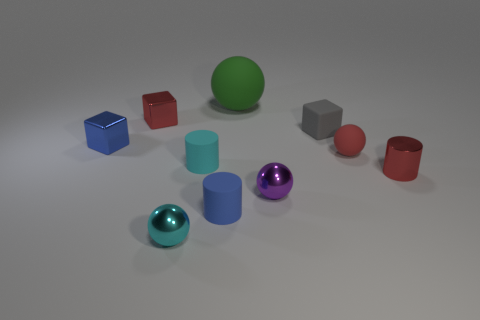Are there any other things that are the same size as the green object?
Keep it short and to the point. No. Is the material of the cyan cylinder the same as the gray thing?
Offer a very short reply. Yes. What number of objects are either tiny red cylinders or big yellow shiny cylinders?
Ensure brevity in your answer.  1. What size is the red block?
Offer a very short reply. Small. Are there fewer tiny blue metal cubes than small spheres?
Make the answer very short. Yes. How many small things have the same color as the metal cylinder?
Your answer should be very brief. 2. Do the tiny metal sphere that is left of the small cyan matte cylinder and the big object have the same color?
Your answer should be compact. No. There is a tiny red thing on the left side of the green matte sphere; what shape is it?
Make the answer very short. Cube. There is a small red object that is on the left side of the tiny matte ball; are there any tiny rubber cylinders left of it?
Give a very brief answer. No. How many gray cubes are the same material as the red ball?
Ensure brevity in your answer.  1. 